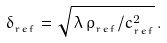Convert formula to latex. <formula><loc_0><loc_0><loc_500><loc_500>\delta _ { _ { r e f } } = \sqrt { { \, \lambda \, \rho _ { _ { r e f } } } / { c _ { _ { r e f } } ^ { 2 } } } \, .</formula> 